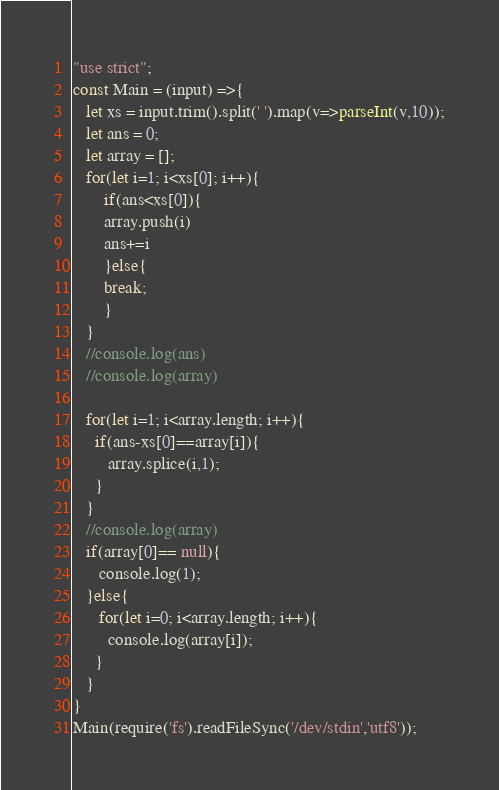Convert code to text. <code><loc_0><loc_0><loc_500><loc_500><_TypeScript_>"use strict";
const Main = (input) =>{
   let xs = input.trim().split(' ').map(v=>parseInt(v,10));
   let ans = 0; 
   let array = [];
   for(let i=1; i<xs[0]; i++){
       if(ans<xs[0]){
       array.push(i)
       ans+=i
       }else{
       break;
       }  
   }
   //console.log(ans)
   //console.log(array)
   
   for(let i=1; i<array.length; i++){
     if(ans-xs[0]==array[i]){
        array.splice(i,1);
     }
   }
   //console.log(array)
   if(array[0]== null){
      console.log(1);
   }else{
      for(let i=0; i<array.length; i++){
        console.log(array[i]);
     }
   }
}
Main(require('fs').readFileSync('/dev/stdin','utf8'));
</code> 